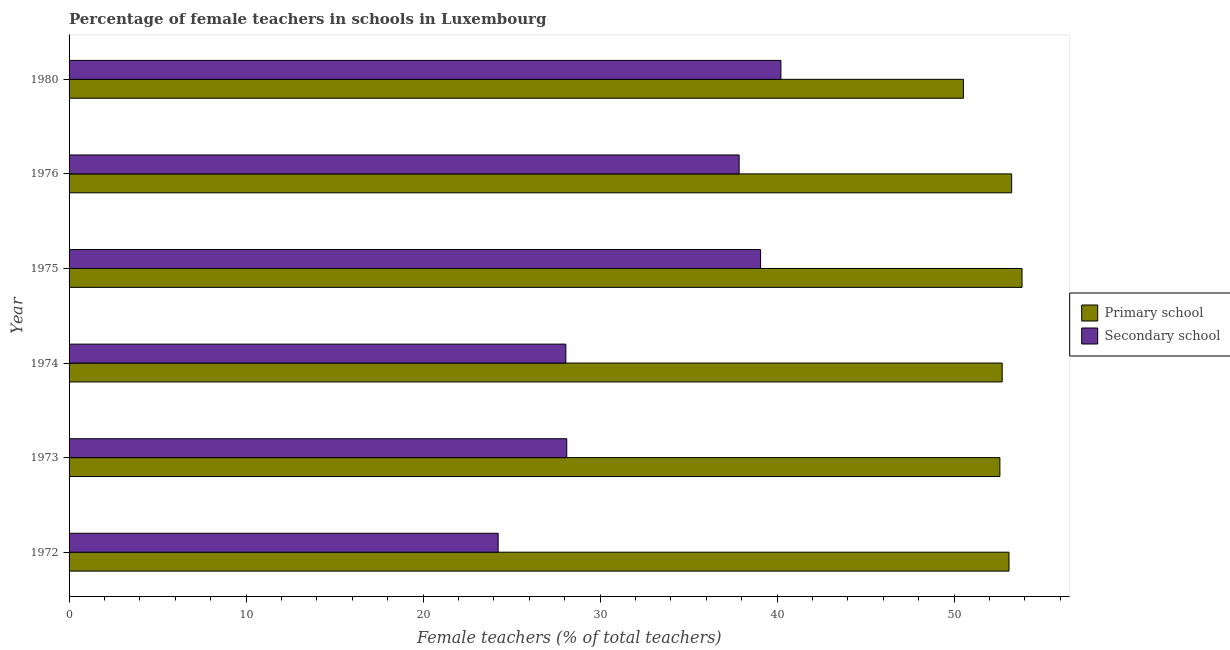Are the number of bars per tick equal to the number of legend labels?
Offer a terse response. Yes. Are the number of bars on each tick of the Y-axis equal?
Ensure brevity in your answer.  Yes. How many bars are there on the 4th tick from the top?
Offer a very short reply. 2. How many bars are there on the 5th tick from the bottom?
Provide a succinct answer. 2. In how many cases, is the number of bars for a given year not equal to the number of legend labels?
Ensure brevity in your answer.  0. What is the percentage of female teachers in primary schools in 1974?
Ensure brevity in your answer.  52.72. Across all years, what is the maximum percentage of female teachers in primary schools?
Your answer should be very brief. 53.84. Across all years, what is the minimum percentage of female teachers in primary schools?
Give a very brief answer. 50.53. In which year was the percentage of female teachers in secondary schools minimum?
Offer a very short reply. 1972. What is the total percentage of female teachers in primary schools in the graph?
Your answer should be very brief. 316.04. What is the difference between the percentage of female teachers in primary schools in 1973 and that in 1980?
Your answer should be compact. 2.06. What is the difference between the percentage of female teachers in primary schools in 1973 and the percentage of female teachers in secondary schools in 1972?
Keep it short and to the point. 28.35. What is the average percentage of female teachers in primary schools per year?
Your answer should be very brief. 52.67. In the year 1976, what is the difference between the percentage of female teachers in primary schools and percentage of female teachers in secondary schools?
Keep it short and to the point. 15.4. Is the percentage of female teachers in primary schools in 1976 less than that in 1980?
Your answer should be compact. No. What is the difference between the highest and the second highest percentage of female teachers in primary schools?
Your answer should be compact. 0.59. What is the difference between the highest and the lowest percentage of female teachers in primary schools?
Make the answer very short. 3.31. What does the 2nd bar from the top in 1973 represents?
Provide a succinct answer. Primary school. What does the 2nd bar from the bottom in 1973 represents?
Your answer should be compact. Secondary school. What is the difference between two consecutive major ticks on the X-axis?
Provide a short and direct response. 10. Are the values on the major ticks of X-axis written in scientific E-notation?
Make the answer very short. No. Does the graph contain any zero values?
Your answer should be compact. No. Where does the legend appear in the graph?
Keep it short and to the point. Center right. How many legend labels are there?
Your response must be concise. 2. What is the title of the graph?
Provide a succinct answer. Percentage of female teachers in schools in Luxembourg. Does "Private consumption" appear as one of the legend labels in the graph?
Your response must be concise. No. What is the label or title of the X-axis?
Your answer should be very brief. Female teachers (% of total teachers). What is the Female teachers (% of total teachers) in Primary school in 1972?
Keep it short and to the point. 53.11. What is the Female teachers (% of total teachers) of Secondary school in 1972?
Your response must be concise. 24.24. What is the Female teachers (% of total teachers) in Primary school in 1973?
Provide a short and direct response. 52.59. What is the Female teachers (% of total teachers) of Secondary school in 1973?
Offer a very short reply. 28.12. What is the Female teachers (% of total teachers) of Primary school in 1974?
Your response must be concise. 52.72. What is the Female teachers (% of total teachers) in Secondary school in 1974?
Keep it short and to the point. 28.07. What is the Female teachers (% of total teachers) of Primary school in 1975?
Your response must be concise. 53.84. What is the Female teachers (% of total teachers) in Secondary school in 1975?
Offer a very short reply. 39.07. What is the Female teachers (% of total teachers) of Primary school in 1976?
Offer a very short reply. 53.25. What is the Female teachers (% of total teachers) in Secondary school in 1976?
Provide a short and direct response. 37.86. What is the Female teachers (% of total teachers) of Primary school in 1980?
Offer a terse response. 50.53. What is the Female teachers (% of total teachers) of Secondary school in 1980?
Provide a short and direct response. 40.22. Across all years, what is the maximum Female teachers (% of total teachers) in Primary school?
Your answer should be compact. 53.84. Across all years, what is the maximum Female teachers (% of total teachers) of Secondary school?
Your answer should be compact. 40.22. Across all years, what is the minimum Female teachers (% of total teachers) of Primary school?
Provide a succinct answer. 50.53. Across all years, what is the minimum Female teachers (% of total teachers) of Secondary school?
Your response must be concise. 24.24. What is the total Female teachers (% of total teachers) in Primary school in the graph?
Ensure brevity in your answer.  316.04. What is the total Female teachers (% of total teachers) in Secondary school in the graph?
Make the answer very short. 197.57. What is the difference between the Female teachers (% of total teachers) in Primary school in 1972 and that in 1973?
Ensure brevity in your answer.  0.52. What is the difference between the Female teachers (% of total teachers) of Secondary school in 1972 and that in 1973?
Give a very brief answer. -3.88. What is the difference between the Female teachers (% of total teachers) of Primary school in 1972 and that in 1974?
Give a very brief answer. 0.39. What is the difference between the Female teachers (% of total teachers) of Secondary school in 1972 and that in 1974?
Give a very brief answer. -3.83. What is the difference between the Female teachers (% of total teachers) of Primary school in 1972 and that in 1975?
Offer a very short reply. -0.74. What is the difference between the Female teachers (% of total teachers) in Secondary school in 1972 and that in 1975?
Your response must be concise. -14.83. What is the difference between the Female teachers (% of total teachers) in Primary school in 1972 and that in 1976?
Ensure brevity in your answer.  -0.15. What is the difference between the Female teachers (% of total teachers) in Secondary school in 1972 and that in 1976?
Your response must be concise. -13.62. What is the difference between the Female teachers (% of total teachers) in Primary school in 1972 and that in 1980?
Offer a terse response. 2.58. What is the difference between the Female teachers (% of total teachers) of Secondary school in 1972 and that in 1980?
Provide a succinct answer. -15.98. What is the difference between the Female teachers (% of total teachers) of Primary school in 1973 and that in 1974?
Your answer should be compact. -0.13. What is the difference between the Female teachers (% of total teachers) in Secondary school in 1973 and that in 1974?
Make the answer very short. 0.05. What is the difference between the Female teachers (% of total teachers) in Primary school in 1973 and that in 1975?
Your response must be concise. -1.25. What is the difference between the Female teachers (% of total teachers) in Secondary school in 1973 and that in 1975?
Ensure brevity in your answer.  -10.95. What is the difference between the Female teachers (% of total teachers) of Primary school in 1973 and that in 1976?
Your answer should be very brief. -0.66. What is the difference between the Female teachers (% of total teachers) in Secondary school in 1973 and that in 1976?
Your answer should be compact. -9.74. What is the difference between the Female teachers (% of total teachers) of Primary school in 1973 and that in 1980?
Your response must be concise. 2.06. What is the difference between the Female teachers (% of total teachers) in Secondary school in 1973 and that in 1980?
Your answer should be very brief. -12.1. What is the difference between the Female teachers (% of total teachers) in Primary school in 1974 and that in 1975?
Offer a terse response. -1.12. What is the difference between the Female teachers (% of total teachers) of Secondary school in 1974 and that in 1975?
Make the answer very short. -11. What is the difference between the Female teachers (% of total teachers) of Primary school in 1974 and that in 1976?
Give a very brief answer. -0.54. What is the difference between the Female teachers (% of total teachers) of Secondary school in 1974 and that in 1976?
Provide a short and direct response. -9.79. What is the difference between the Female teachers (% of total teachers) of Primary school in 1974 and that in 1980?
Offer a very short reply. 2.19. What is the difference between the Female teachers (% of total teachers) of Secondary school in 1974 and that in 1980?
Offer a terse response. -12.15. What is the difference between the Female teachers (% of total teachers) in Primary school in 1975 and that in 1976?
Make the answer very short. 0.59. What is the difference between the Female teachers (% of total teachers) in Secondary school in 1975 and that in 1976?
Provide a short and direct response. 1.21. What is the difference between the Female teachers (% of total teachers) of Primary school in 1975 and that in 1980?
Make the answer very short. 3.31. What is the difference between the Female teachers (% of total teachers) of Secondary school in 1975 and that in 1980?
Your response must be concise. -1.15. What is the difference between the Female teachers (% of total teachers) in Primary school in 1976 and that in 1980?
Your answer should be compact. 2.73. What is the difference between the Female teachers (% of total teachers) in Secondary school in 1976 and that in 1980?
Provide a succinct answer. -2.36. What is the difference between the Female teachers (% of total teachers) of Primary school in 1972 and the Female teachers (% of total teachers) of Secondary school in 1973?
Give a very brief answer. 24.99. What is the difference between the Female teachers (% of total teachers) in Primary school in 1972 and the Female teachers (% of total teachers) in Secondary school in 1974?
Your response must be concise. 25.04. What is the difference between the Female teachers (% of total teachers) of Primary school in 1972 and the Female teachers (% of total teachers) of Secondary school in 1975?
Give a very brief answer. 14.04. What is the difference between the Female teachers (% of total teachers) in Primary school in 1972 and the Female teachers (% of total teachers) in Secondary school in 1976?
Your answer should be compact. 15.25. What is the difference between the Female teachers (% of total teachers) in Primary school in 1972 and the Female teachers (% of total teachers) in Secondary school in 1980?
Your answer should be very brief. 12.89. What is the difference between the Female teachers (% of total teachers) of Primary school in 1973 and the Female teachers (% of total teachers) of Secondary school in 1974?
Offer a terse response. 24.52. What is the difference between the Female teachers (% of total teachers) of Primary school in 1973 and the Female teachers (% of total teachers) of Secondary school in 1975?
Your answer should be very brief. 13.52. What is the difference between the Female teachers (% of total teachers) in Primary school in 1973 and the Female teachers (% of total teachers) in Secondary school in 1976?
Your response must be concise. 14.73. What is the difference between the Female teachers (% of total teachers) of Primary school in 1973 and the Female teachers (% of total teachers) of Secondary school in 1980?
Offer a very short reply. 12.37. What is the difference between the Female teachers (% of total teachers) of Primary school in 1974 and the Female teachers (% of total teachers) of Secondary school in 1975?
Your answer should be very brief. 13.65. What is the difference between the Female teachers (% of total teachers) of Primary school in 1974 and the Female teachers (% of total teachers) of Secondary school in 1976?
Keep it short and to the point. 14.86. What is the difference between the Female teachers (% of total teachers) of Primary school in 1974 and the Female teachers (% of total teachers) of Secondary school in 1980?
Ensure brevity in your answer.  12.5. What is the difference between the Female teachers (% of total teachers) in Primary school in 1975 and the Female teachers (% of total teachers) in Secondary school in 1976?
Offer a very short reply. 15.98. What is the difference between the Female teachers (% of total teachers) in Primary school in 1975 and the Female teachers (% of total teachers) in Secondary school in 1980?
Offer a terse response. 13.62. What is the difference between the Female teachers (% of total teachers) of Primary school in 1976 and the Female teachers (% of total teachers) of Secondary school in 1980?
Offer a very short reply. 13.04. What is the average Female teachers (% of total teachers) of Primary school per year?
Ensure brevity in your answer.  52.67. What is the average Female teachers (% of total teachers) of Secondary school per year?
Offer a terse response. 32.93. In the year 1972, what is the difference between the Female teachers (% of total teachers) in Primary school and Female teachers (% of total teachers) in Secondary school?
Provide a short and direct response. 28.86. In the year 1973, what is the difference between the Female teachers (% of total teachers) of Primary school and Female teachers (% of total teachers) of Secondary school?
Your answer should be compact. 24.47. In the year 1974, what is the difference between the Female teachers (% of total teachers) in Primary school and Female teachers (% of total teachers) in Secondary school?
Your answer should be very brief. 24.65. In the year 1975, what is the difference between the Female teachers (% of total teachers) of Primary school and Female teachers (% of total teachers) of Secondary school?
Your answer should be very brief. 14.77. In the year 1976, what is the difference between the Female teachers (% of total teachers) in Primary school and Female teachers (% of total teachers) in Secondary school?
Provide a succinct answer. 15.4. In the year 1980, what is the difference between the Female teachers (% of total teachers) of Primary school and Female teachers (% of total teachers) of Secondary school?
Your answer should be compact. 10.31. What is the ratio of the Female teachers (% of total teachers) of Primary school in 1972 to that in 1973?
Offer a terse response. 1.01. What is the ratio of the Female teachers (% of total teachers) in Secondary school in 1972 to that in 1973?
Provide a short and direct response. 0.86. What is the ratio of the Female teachers (% of total teachers) of Primary school in 1972 to that in 1974?
Give a very brief answer. 1.01. What is the ratio of the Female teachers (% of total teachers) in Secondary school in 1972 to that in 1974?
Offer a very short reply. 0.86. What is the ratio of the Female teachers (% of total teachers) of Primary school in 1972 to that in 1975?
Provide a succinct answer. 0.99. What is the ratio of the Female teachers (% of total teachers) in Secondary school in 1972 to that in 1975?
Provide a succinct answer. 0.62. What is the ratio of the Female teachers (% of total teachers) of Primary school in 1972 to that in 1976?
Offer a very short reply. 1. What is the ratio of the Female teachers (% of total teachers) of Secondary school in 1972 to that in 1976?
Give a very brief answer. 0.64. What is the ratio of the Female teachers (% of total teachers) in Primary school in 1972 to that in 1980?
Your response must be concise. 1.05. What is the ratio of the Female teachers (% of total teachers) in Secondary school in 1972 to that in 1980?
Offer a terse response. 0.6. What is the ratio of the Female teachers (% of total teachers) of Primary school in 1973 to that in 1974?
Give a very brief answer. 1. What is the ratio of the Female teachers (% of total teachers) of Secondary school in 1973 to that in 1974?
Provide a short and direct response. 1. What is the ratio of the Female teachers (% of total teachers) of Primary school in 1973 to that in 1975?
Offer a very short reply. 0.98. What is the ratio of the Female teachers (% of total teachers) of Secondary school in 1973 to that in 1975?
Give a very brief answer. 0.72. What is the ratio of the Female teachers (% of total teachers) in Primary school in 1973 to that in 1976?
Offer a terse response. 0.99. What is the ratio of the Female teachers (% of total teachers) of Secondary school in 1973 to that in 1976?
Provide a short and direct response. 0.74. What is the ratio of the Female teachers (% of total teachers) of Primary school in 1973 to that in 1980?
Ensure brevity in your answer.  1.04. What is the ratio of the Female teachers (% of total teachers) of Secondary school in 1973 to that in 1980?
Your response must be concise. 0.7. What is the ratio of the Female teachers (% of total teachers) in Primary school in 1974 to that in 1975?
Provide a succinct answer. 0.98. What is the ratio of the Female teachers (% of total teachers) of Secondary school in 1974 to that in 1975?
Provide a succinct answer. 0.72. What is the ratio of the Female teachers (% of total teachers) of Secondary school in 1974 to that in 1976?
Offer a terse response. 0.74. What is the ratio of the Female teachers (% of total teachers) in Primary school in 1974 to that in 1980?
Provide a succinct answer. 1.04. What is the ratio of the Female teachers (% of total teachers) in Secondary school in 1974 to that in 1980?
Your answer should be very brief. 0.7. What is the ratio of the Female teachers (% of total teachers) in Primary school in 1975 to that in 1976?
Offer a terse response. 1.01. What is the ratio of the Female teachers (% of total teachers) in Secondary school in 1975 to that in 1976?
Your answer should be very brief. 1.03. What is the ratio of the Female teachers (% of total teachers) in Primary school in 1975 to that in 1980?
Provide a short and direct response. 1.07. What is the ratio of the Female teachers (% of total teachers) in Secondary school in 1975 to that in 1980?
Your response must be concise. 0.97. What is the ratio of the Female teachers (% of total teachers) in Primary school in 1976 to that in 1980?
Offer a very short reply. 1.05. What is the ratio of the Female teachers (% of total teachers) of Secondary school in 1976 to that in 1980?
Make the answer very short. 0.94. What is the difference between the highest and the second highest Female teachers (% of total teachers) in Primary school?
Keep it short and to the point. 0.59. What is the difference between the highest and the second highest Female teachers (% of total teachers) of Secondary school?
Make the answer very short. 1.15. What is the difference between the highest and the lowest Female teachers (% of total teachers) of Primary school?
Your answer should be compact. 3.31. What is the difference between the highest and the lowest Female teachers (% of total teachers) of Secondary school?
Offer a terse response. 15.98. 